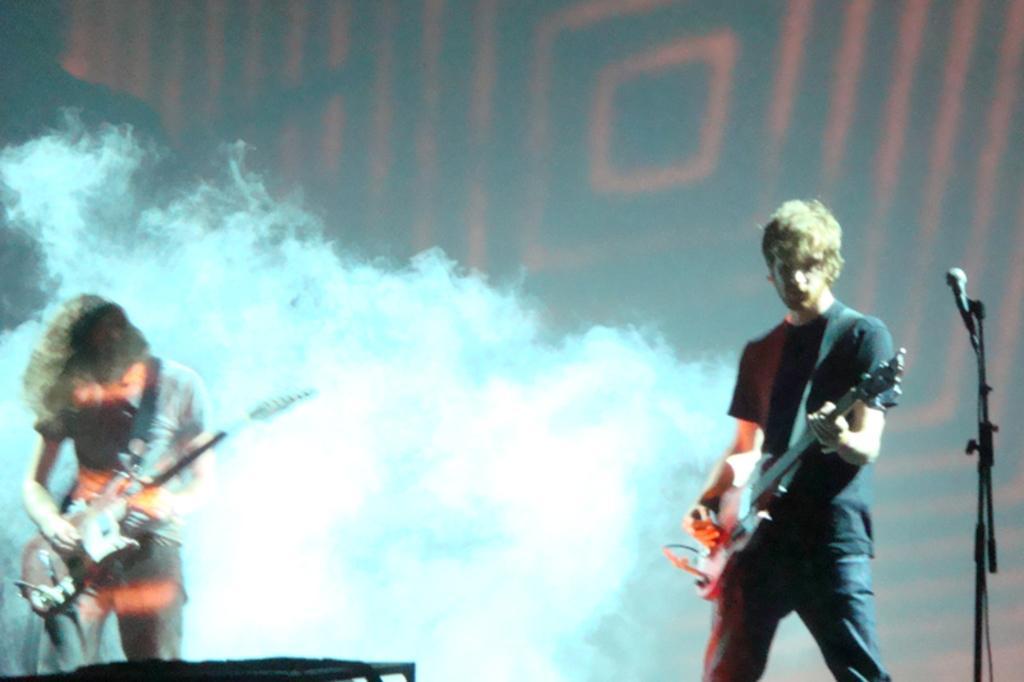Could you give a brief overview of what you see in this image? In this image I can see two persons are playing the guitar. On the right side of the image there is a mike stand. 